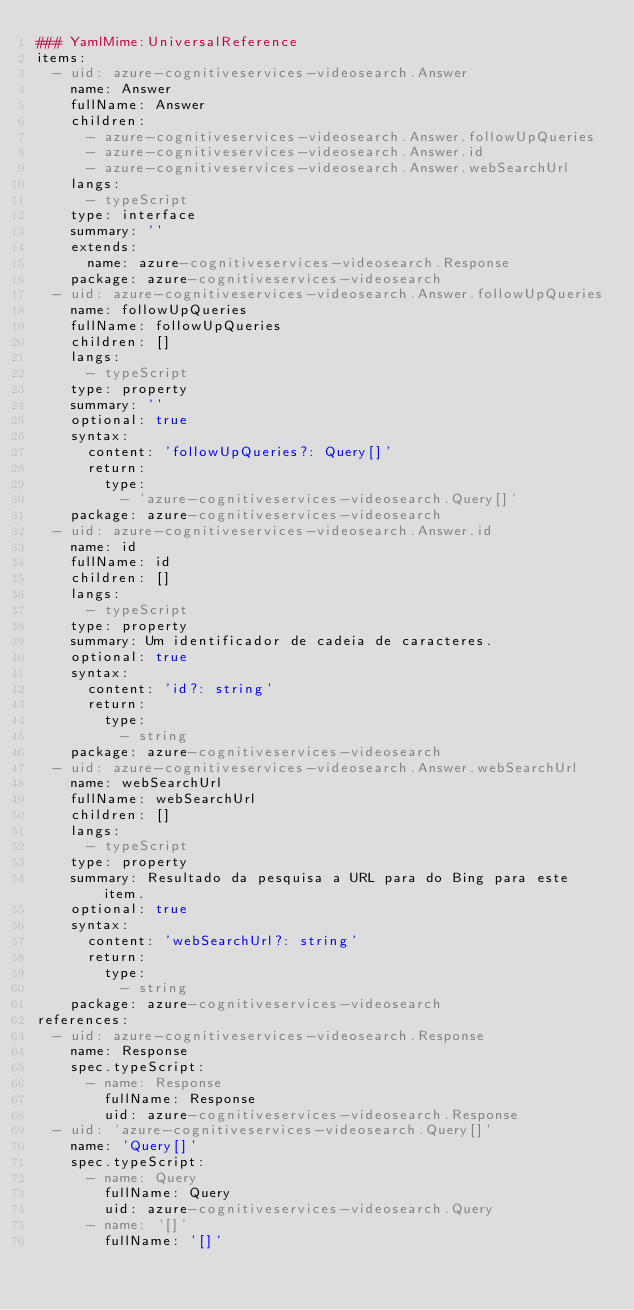Convert code to text. <code><loc_0><loc_0><loc_500><loc_500><_YAML_>### YamlMime:UniversalReference
items:
  - uid: azure-cognitiveservices-videosearch.Answer
    name: Answer
    fullName: Answer
    children:
      - azure-cognitiveservices-videosearch.Answer.followUpQueries
      - azure-cognitiveservices-videosearch.Answer.id
      - azure-cognitiveservices-videosearch.Answer.webSearchUrl
    langs:
      - typeScript
    type: interface
    summary: ''
    extends:
      name: azure-cognitiveservices-videosearch.Response
    package: azure-cognitiveservices-videosearch
  - uid: azure-cognitiveservices-videosearch.Answer.followUpQueries
    name: followUpQueries
    fullName: followUpQueries
    children: []
    langs:
      - typeScript
    type: property
    summary: ''
    optional: true
    syntax:
      content: 'followUpQueries?: Query[]'
      return:
        type:
          - 'azure-cognitiveservices-videosearch.Query[]'
    package: azure-cognitiveservices-videosearch
  - uid: azure-cognitiveservices-videosearch.Answer.id
    name: id
    fullName: id
    children: []
    langs:
      - typeScript
    type: property
    summary: Um identificador de cadeia de caracteres.
    optional: true
    syntax:
      content: 'id?: string'
      return:
        type:
          - string
    package: azure-cognitiveservices-videosearch
  - uid: azure-cognitiveservices-videosearch.Answer.webSearchUrl
    name: webSearchUrl
    fullName: webSearchUrl
    children: []
    langs:
      - typeScript
    type: property
    summary: Resultado da pesquisa a URL para do Bing para este item.
    optional: true
    syntax:
      content: 'webSearchUrl?: string'
      return:
        type:
          - string
    package: azure-cognitiveservices-videosearch
references:
  - uid: azure-cognitiveservices-videosearch.Response
    name: Response
    spec.typeScript:
      - name: Response
        fullName: Response
        uid: azure-cognitiveservices-videosearch.Response
  - uid: 'azure-cognitiveservices-videosearch.Query[]'
    name: 'Query[]'
    spec.typeScript:
      - name: Query
        fullName: Query
        uid: azure-cognitiveservices-videosearch.Query
      - name: '[]'
        fullName: '[]'</code> 